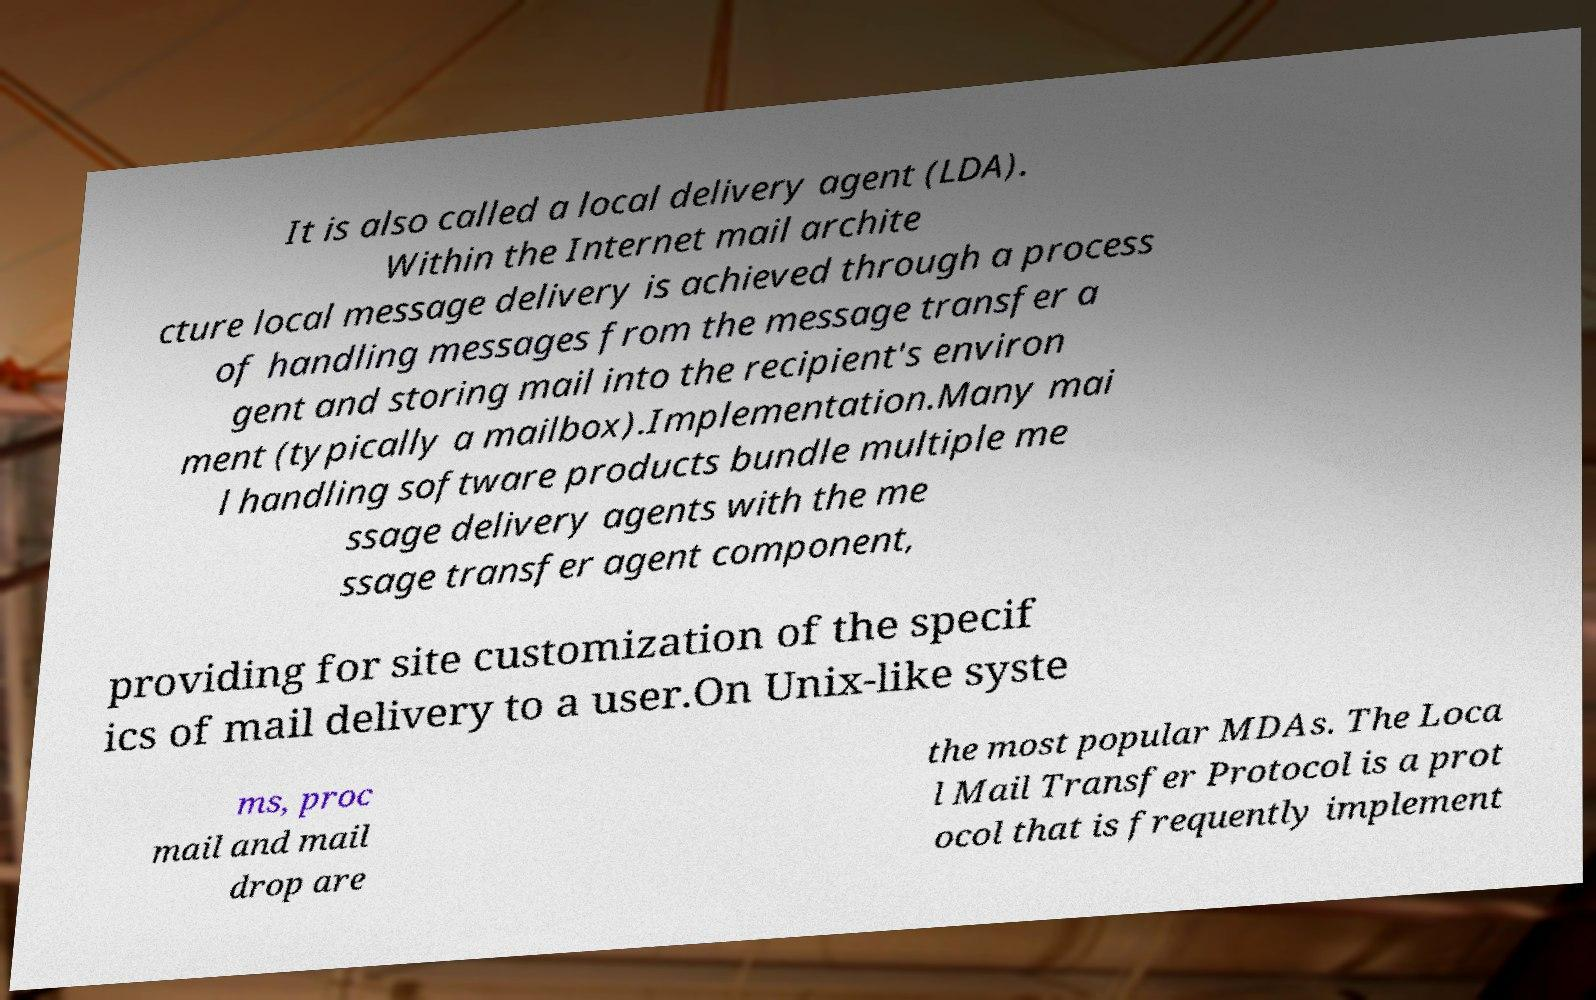There's text embedded in this image that I need extracted. Can you transcribe it verbatim? It is also called a local delivery agent (LDA). Within the Internet mail archite cture local message delivery is achieved through a process of handling messages from the message transfer a gent and storing mail into the recipient's environ ment (typically a mailbox).Implementation.Many mai l handling software products bundle multiple me ssage delivery agents with the me ssage transfer agent component, providing for site customization of the specif ics of mail delivery to a user.On Unix-like syste ms, proc mail and mail drop are the most popular MDAs. The Loca l Mail Transfer Protocol is a prot ocol that is frequently implement 